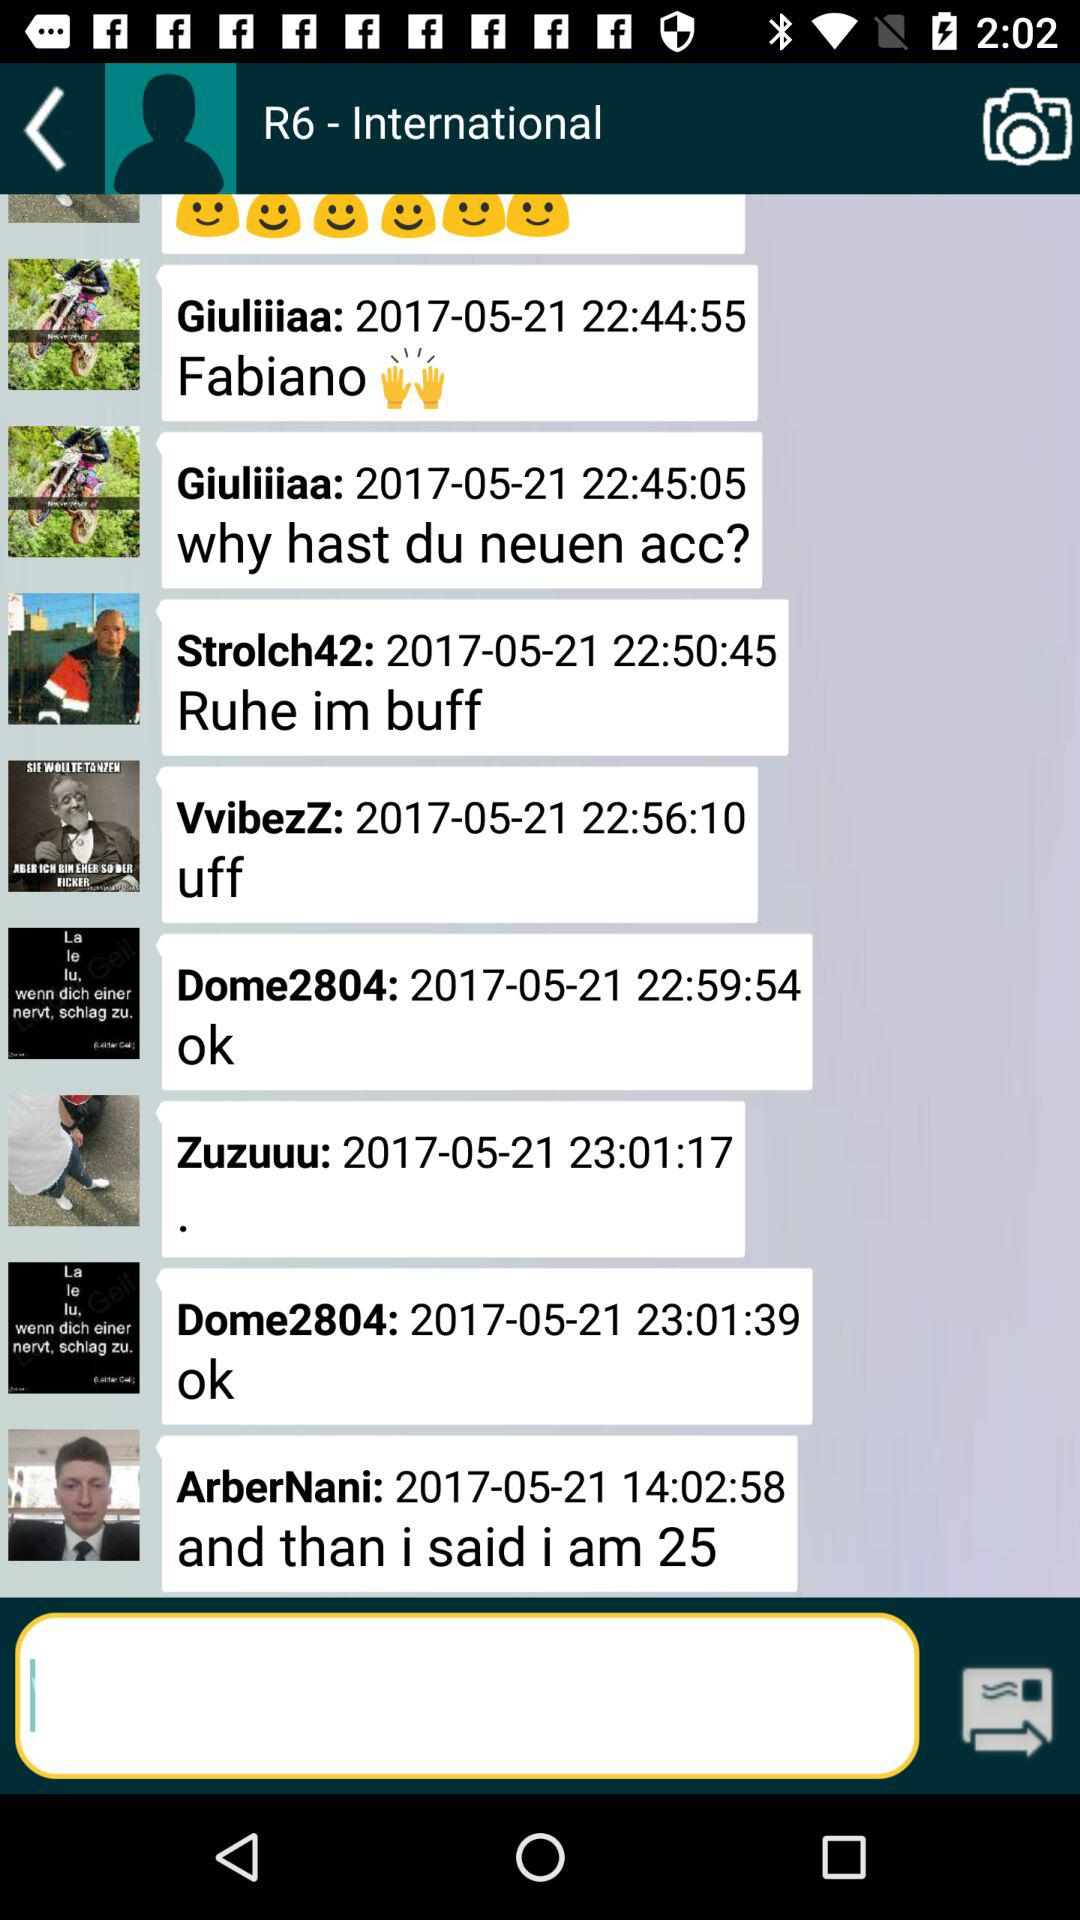How many messages have been sent by Giuliiiiaa?
Answer the question using a single word or phrase. 2 